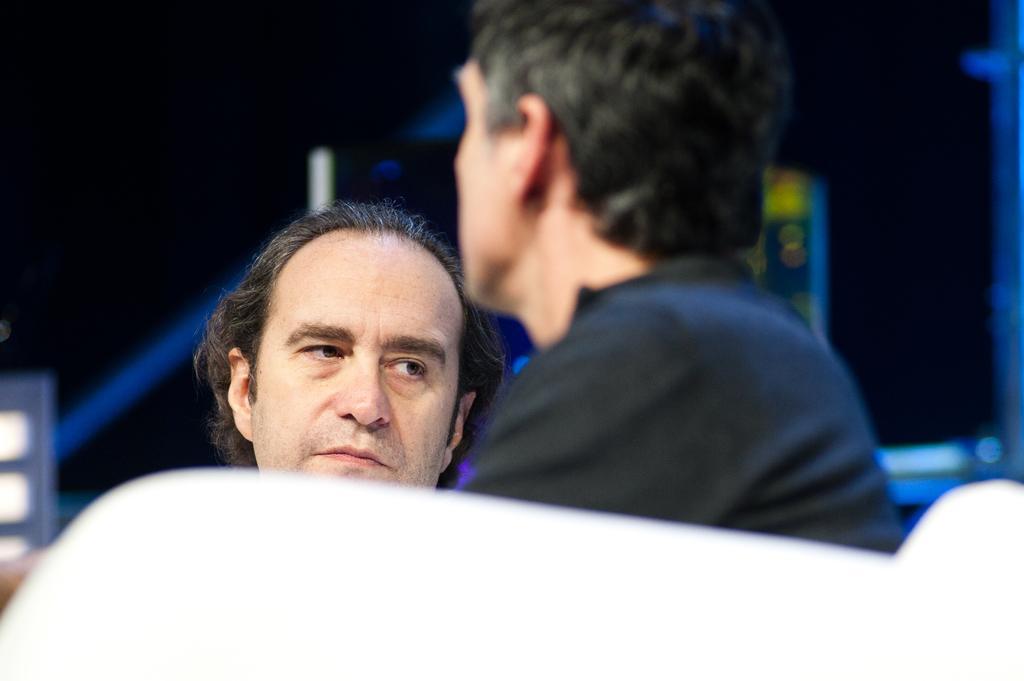Could you give a brief overview of what you see in this image? In this image we can see men. 